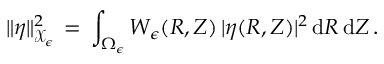Convert formula to latex. <formula><loc_0><loc_0><loc_500><loc_500>\| \eta \| _ { \mathcal { X } _ { \epsilon } } ^ { 2 } \, = \, \int _ { \Omega _ { \epsilon } } W _ { \epsilon } ( R , Z ) \, | \eta ( R , Z ) | ^ { 2 } \, d R \, d Z \, .</formula> 